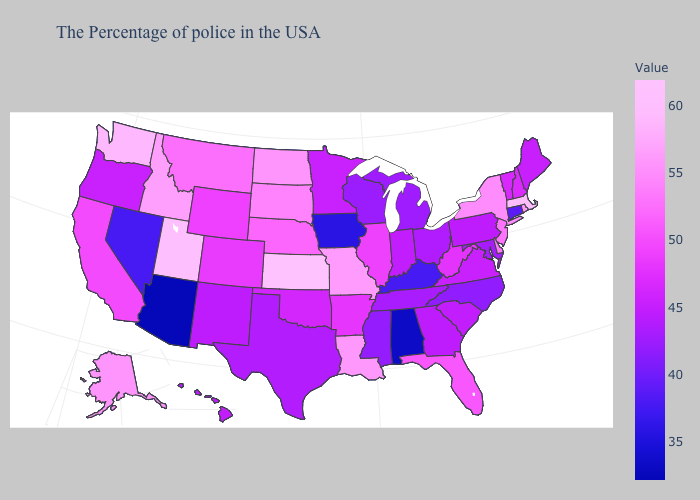Among the states that border Washington , which have the highest value?
Give a very brief answer. Idaho. Among the states that border Alabama , which have the highest value?
Give a very brief answer. Florida. Does California have a higher value than New Mexico?
Answer briefly. Yes. Does Colorado have a higher value than Maine?
Be succinct. Yes. Does Arizona have the lowest value in the USA?
Quick response, please. Yes. Which states hav the highest value in the Northeast?
Answer briefly. Massachusetts. Is the legend a continuous bar?
Quick response, please. Yes. 